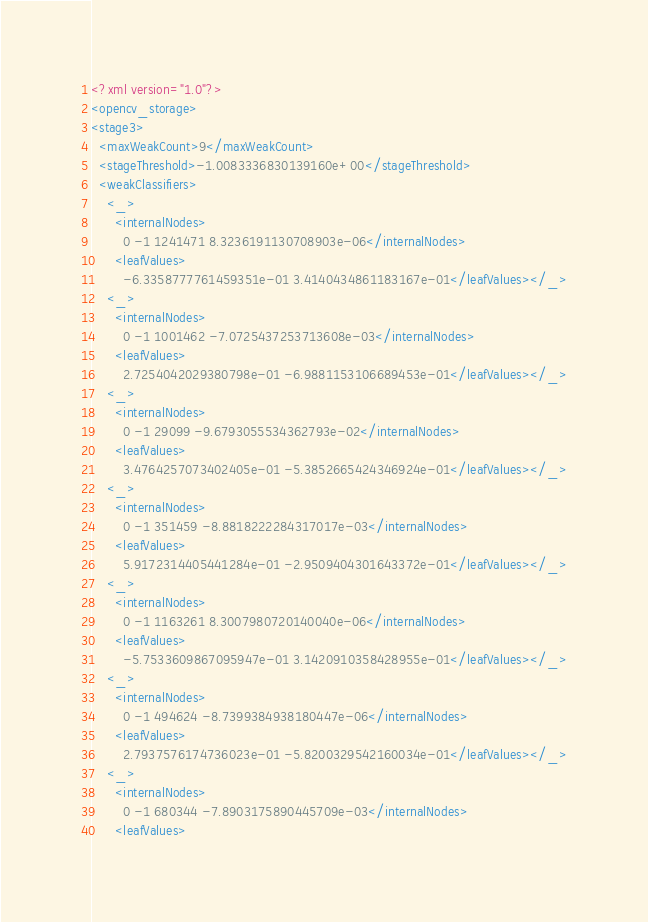<code> <loc_0><loc_0><loc_500><loc_500><_XML_><?xml version="1.0"?>
<opencv_storage>
<stage3>
  <maxWeakCount>9</maxWeakCount>
  <stageThreshold>-1.0083336830139160e+00</stageThreshold>
  <weakClassifiers>
    <_>
      <internalNodes>
        0 -1 1241471 8.3236191130708903e-06</internalNodes>
      <leafValues>
        -6.3358777761459351e-01 3.4140434861183167e-01</leafValues></_>
    <_>
      <internalNodes>
        0 -1 1001462 -7.0725437253713608e-03</internalNodes>
      <leafValues>
        2.7254042029380798e-01 -6.9881153106689453e-01</leafValues></_>
    <_>
      <internalNodes>
        0 -1 29099 -9.6793055534362793e-02</internalNodes>
      <leafValues>
        3.4764257073402405e-01 -5.3852665424346924e-01</leafValues></_>
    <_>
      <internalNodes>
        0 -1 351459 -8.8818222284317017e-03</internalNodes>
      <leafValues>
        5.9172314405441284e-01 -2.9509404301643372e-01</leafValues></_>
    <_>
      <internalNodes>
        0 -1 1163261 8.3007980720140040e-06</internalNodes>
      <leafValues>
        -5.7533609867095947e-01 3.1420910358428955e-01</leafValues></_>
    <_>
      <internalNodes>
        0 -1 494624 -8.7399384938180447e-06</internalNodes>
      <leafValues>
        2.7937576174736023e-01 -5.8200329542160034e-01</leafValues></_>
    <_>
      <internalNodes>
        0 -1 680344 -7.8903175890445709e-03</internalNodes>
      <leafValues></code> 